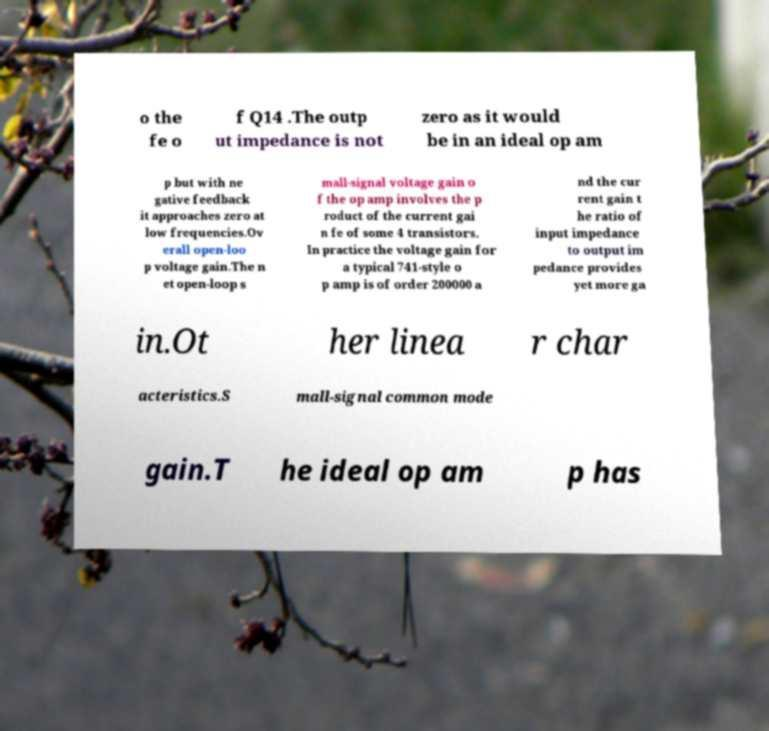Please read and relay the text visible in this image. What does it say? o the fe o f Q14 .The outp ut impedance is not zero as it would be in an ideal op am p but with ne gative feedback it approaches zero at low frequencies.Ov erall open-loo p voltage gain.The n et open-loop s mall-signal voltage gain o f the op amp involves the p roduct of the current gai n fe of some 4 transistors. In practice the voltage gain for a typical 741-style o p amp is of order 200000 a nd the cur rent gain t he ratio of input impedance to output im pedance provides yet more ga in.Ot her linea r char acteristics.S mall-signal common mode gain.T he ideal op am p has 